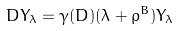Convert formula to latex. <formula><loc_0><loc_0><loc_500><loc_500>D Y _ { \lambda } = \gamma ( D ) ( \lambda + \rho ^ { B } ) Y _ { \lambda }</formula> 